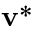Convert formula to latex. <formula><loc_0><loc_0><loc_500><loc_500>v ^ { * }</formula> 